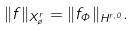<formula> <loc_0><loc_0><loc_500><loc_500>\| f \| _ { X ^ { r } _ { \tau } } = \| f _ { \Phi } \| _ { H ^ { r , 0 } } .</formula> 